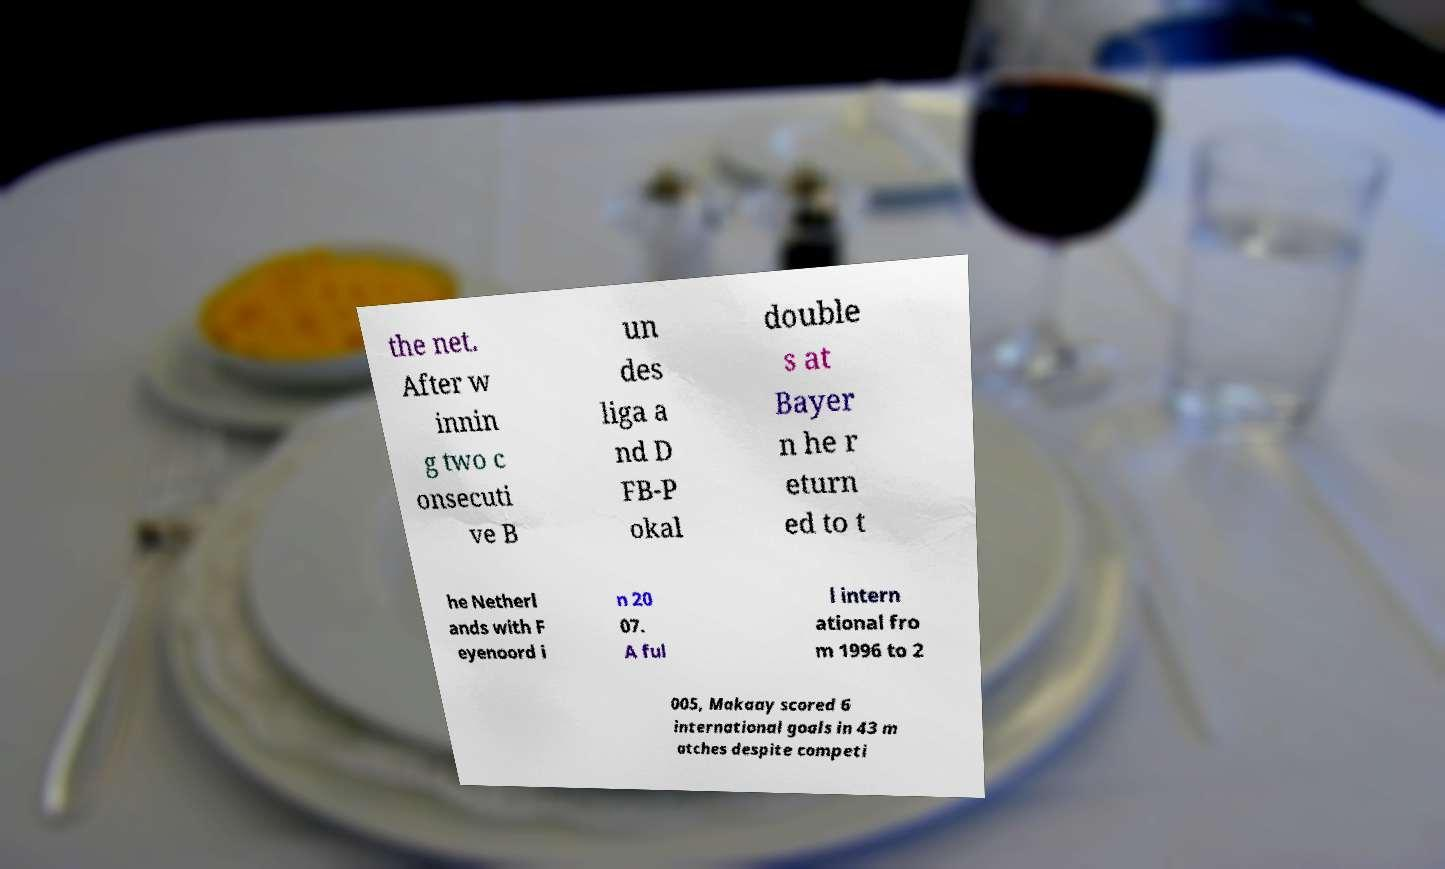Can you accurately transcribe the text from the provided image for me? the net. After w innin g two c onsecuti ve B un des liga a nd D FB-P okal double s at Bayer n he r eturn ed to t he Netherl ands with F eyenoord i n 20 07. A ful l intern ational fro m 1996 to 2 005, Makaay scored 6 international goals in 43 m atches despite competi 